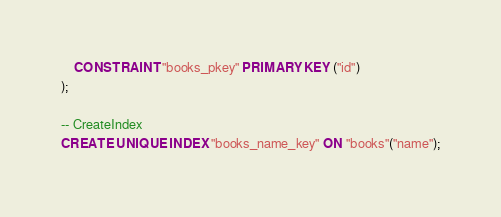<code> <loc_0><loc_0><loc_500><loc_500><_SQL_>
    CONSTRAINT "books_pkey" PRIMARY KEY ("id")
);

-- CreateIndex
CREATE UNIQUE INDEX "books_name_key" ON "books"("name");
</code> 